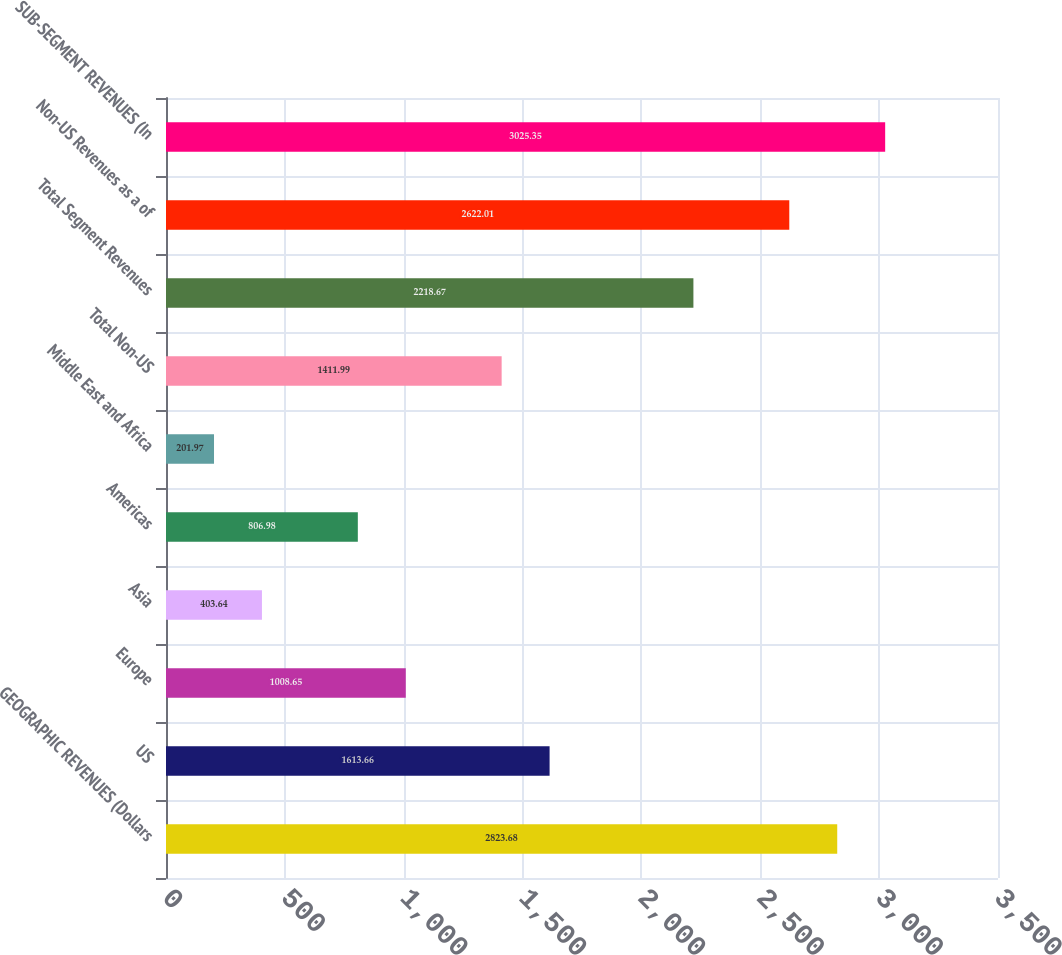Convert chart. <chart><loc_0><loc_0><loc_500><loc_500><bar_chart><fcel>GEOGRAPHIC REVENUES (Dollars<fcel>US<fcel>Europe<fcel>Asia<fcel>Americas<fcel>Middle East and Africa<fcel>Total Non-US<fcel>Total Segment Revenues<fcel>Non-US Revenues as a of<fcel>SUB-SEGMENT REVENUES (In<nl><fcel>2823.68<fcel>1613.66<fcel>1008.65<fcel>403.64<fcel>806.98<fcel>201.97<fcel>1411.99<fcel>2218.67<fcel>2622.01<fcel>3025.35<nl></chart> 